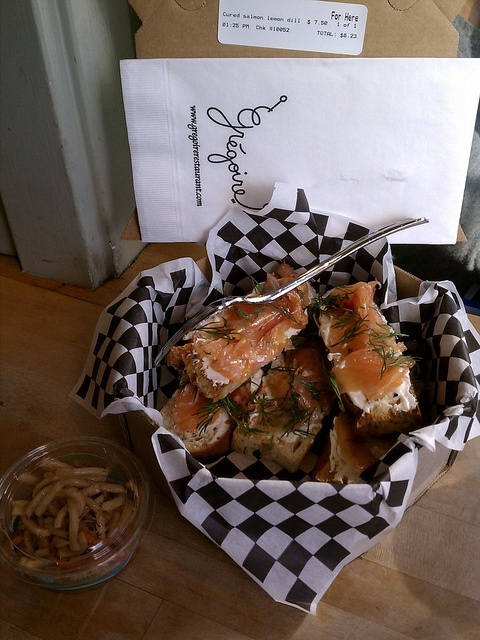Describe the objects in this image and their specific colors. I can see bowl in black, maroon, darkgray, and gray tones, bowl in black, maroon, and gray tones, sandwich in black, brown, maroon, and gray tones, sandwich in black, maroon, and gray tones, and sandwich in black, maroon, and brown tones in this image. 